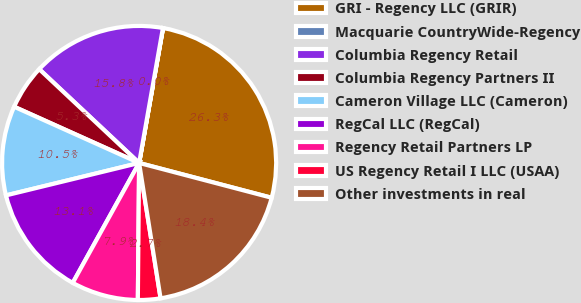Convert chart to OTSL. <chart><loc_0><loc_0><loc_500><loc_500><pie_chart><fcel>GRI - Regency LLC (GRIR)<fcel>Macquarie CountryWide-Regency<fcel>Columbia Regency Retail<fcel>Columbia Regency Partners II<fcel>Cameron Village LLC (Cameron)<fcel>RegCal LLC (RegCal)<fcel>Regency Retail Partners LP<fcel>US Regency Retail I LLC (USAA)<fcel>Other investments in real<nl><fcel>26.29%<fcel>0.02%<fcel>15.78%<fcel>5.27%<fcel>10.53%<fcel>13.15%<fcel>7.9%<fcel>2.65%<fcel>18.41%<nl></chart> 